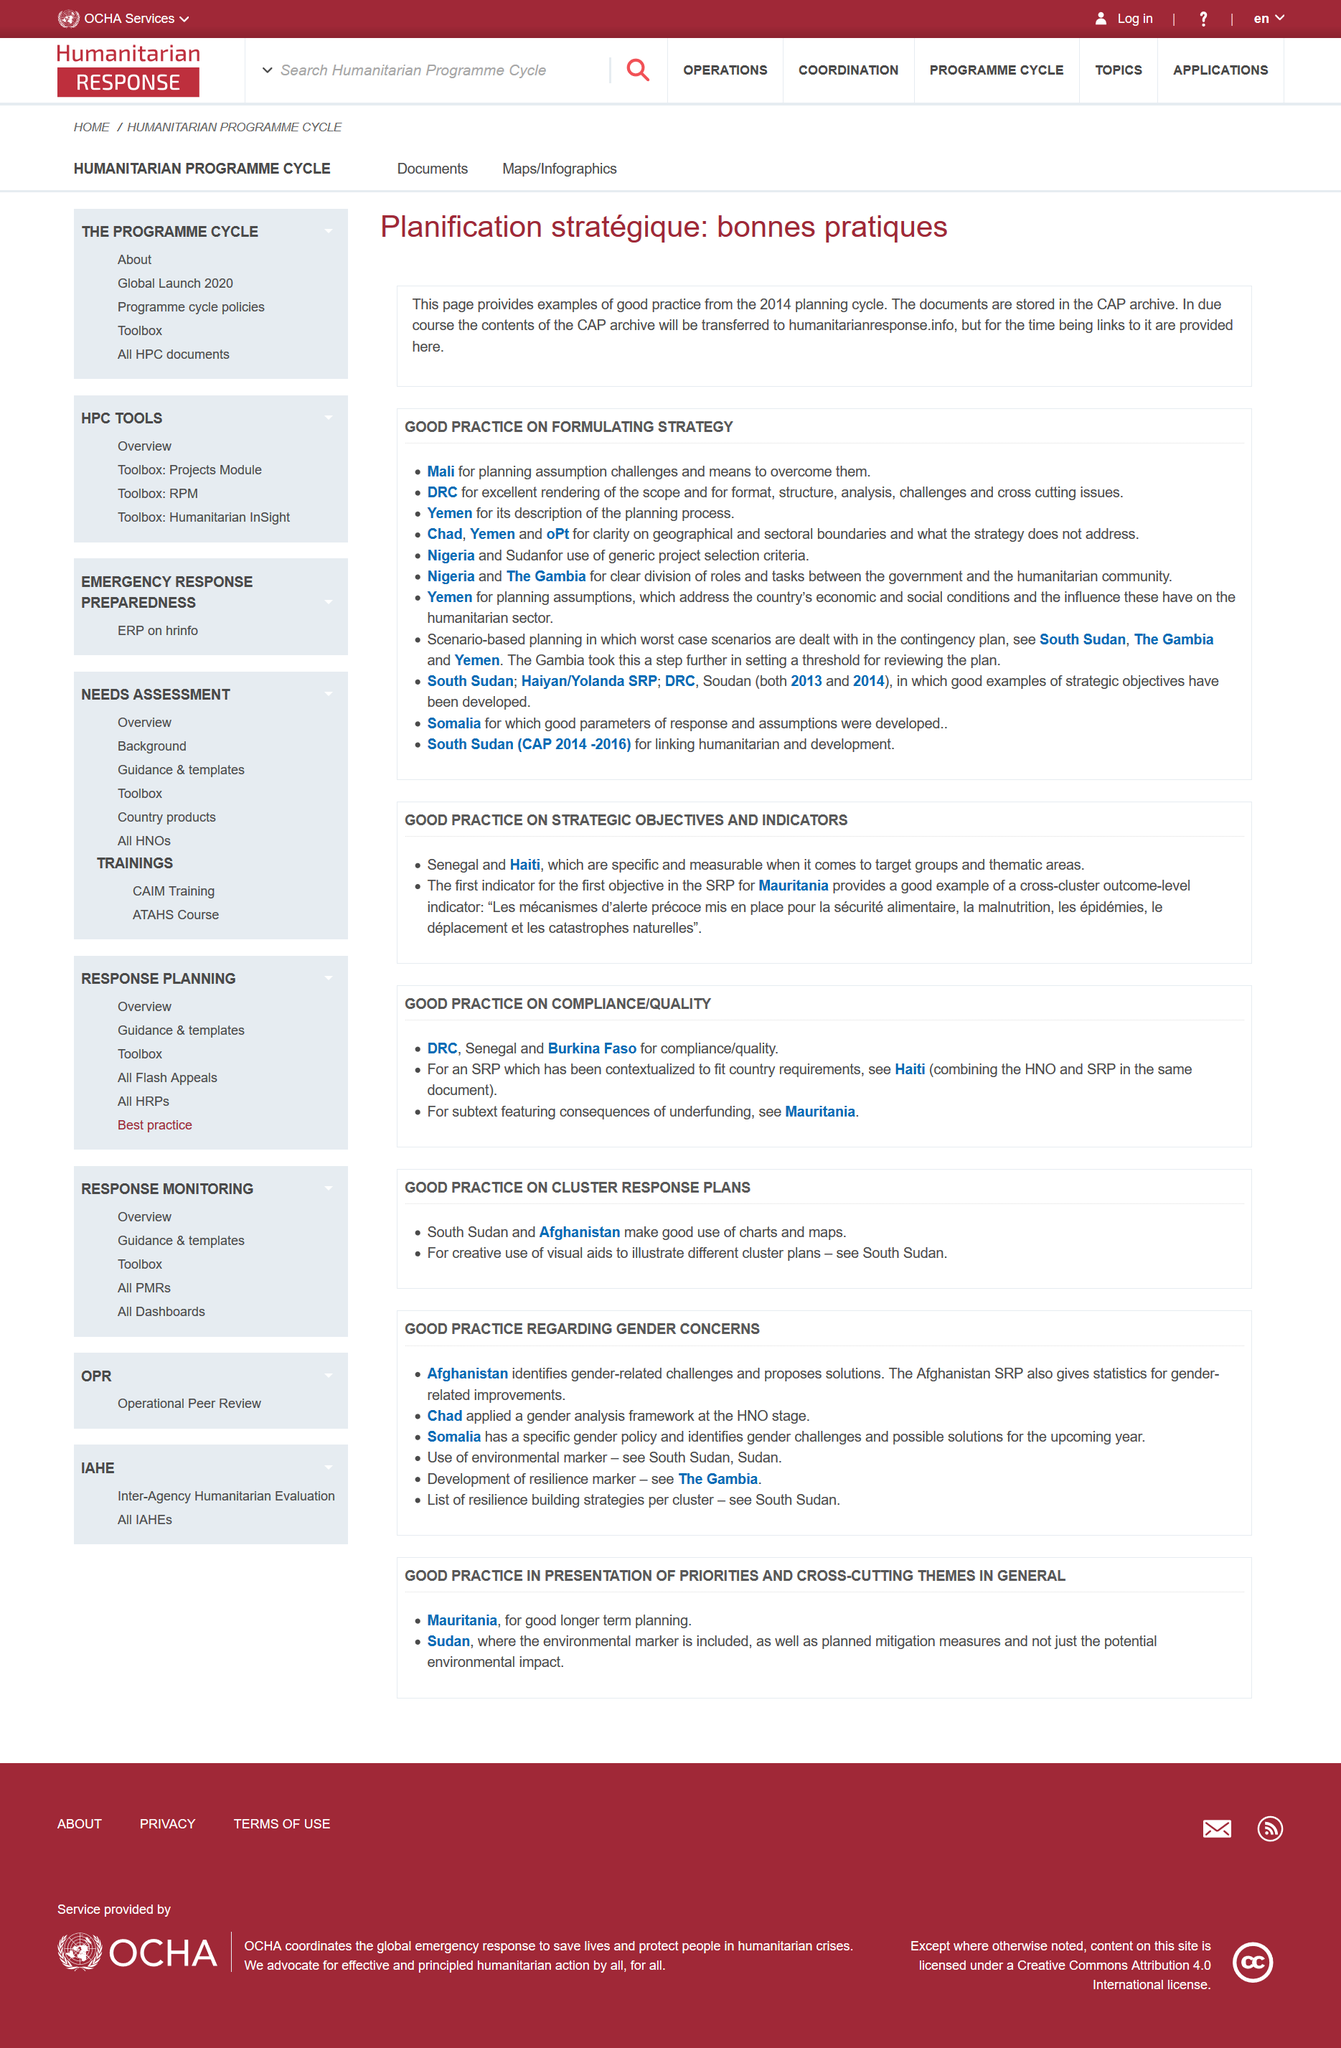Identify some key points in this picture. Nigeria uses a generic project selection criteria, which is specified in the "Good Practice on Formulating Strategy" list. 